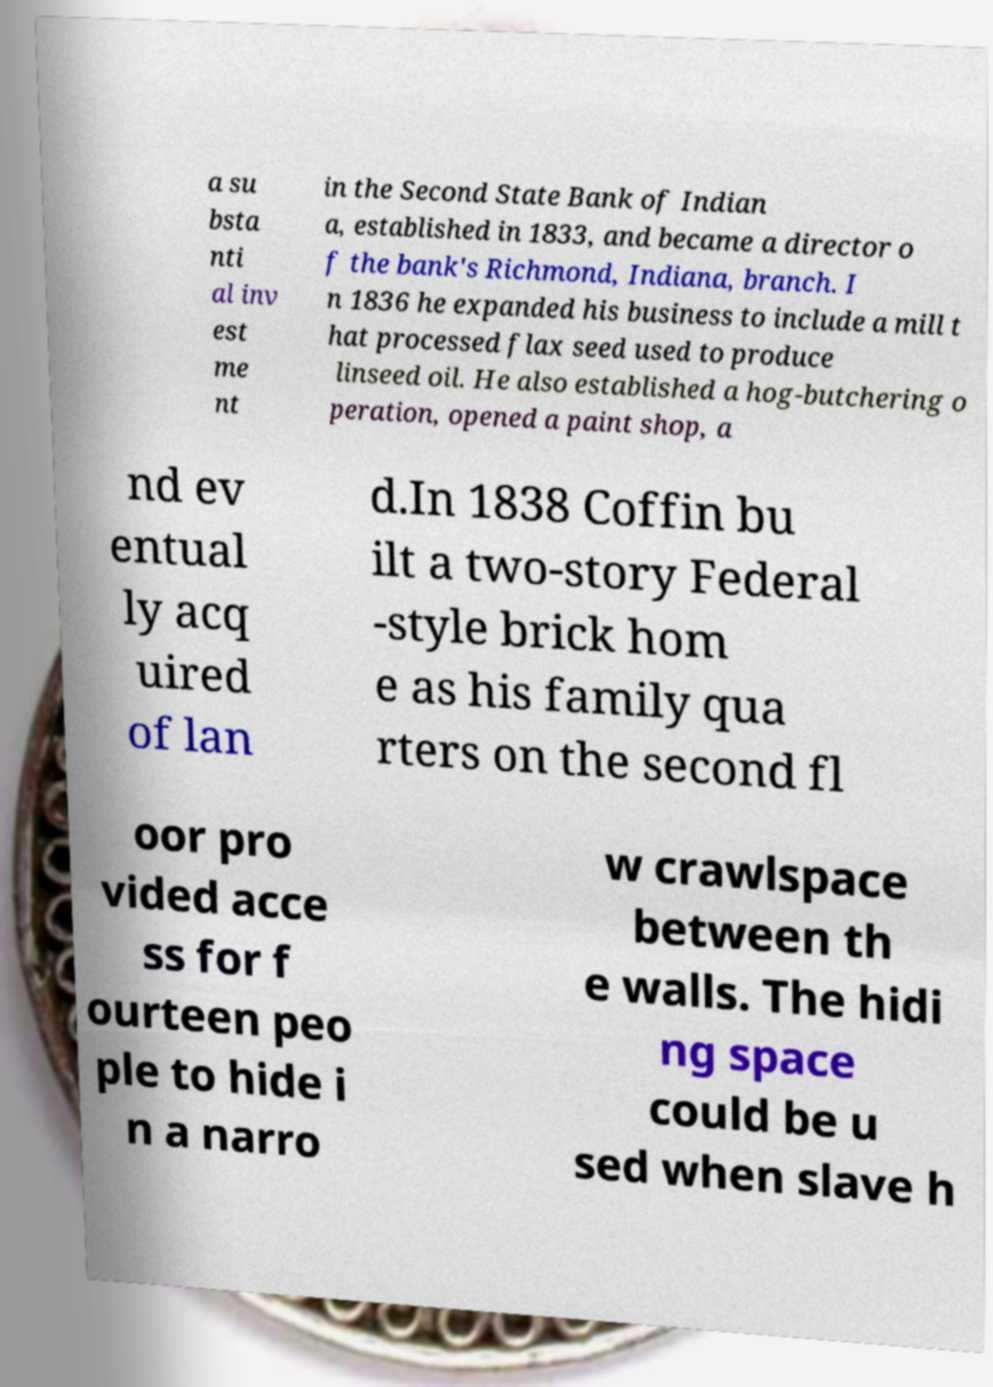Please read and relay the text visible in this image. What does it say? a su bsta nti al inv est me nt in the Second State Bank of Indian a, established in 1833, and became a director o f the bank's Richmond, Indiana, branch. I n 1836 he expanded his business to include a mill t hat processed flax seed used to produce linseed oil. He also established a hog-butchering o peration, opened a paint shop, a nd ev entual ly acq uired of lan d.In 1838 Coffin bu ilt a two-story Federal -style brick hom e as his family qua rters on the second fl oor pro vided acce ss for f ourteen peo ple to hide i n a narro w crawlspace between th e walls. The hidi ng space could be u sed when slave h 